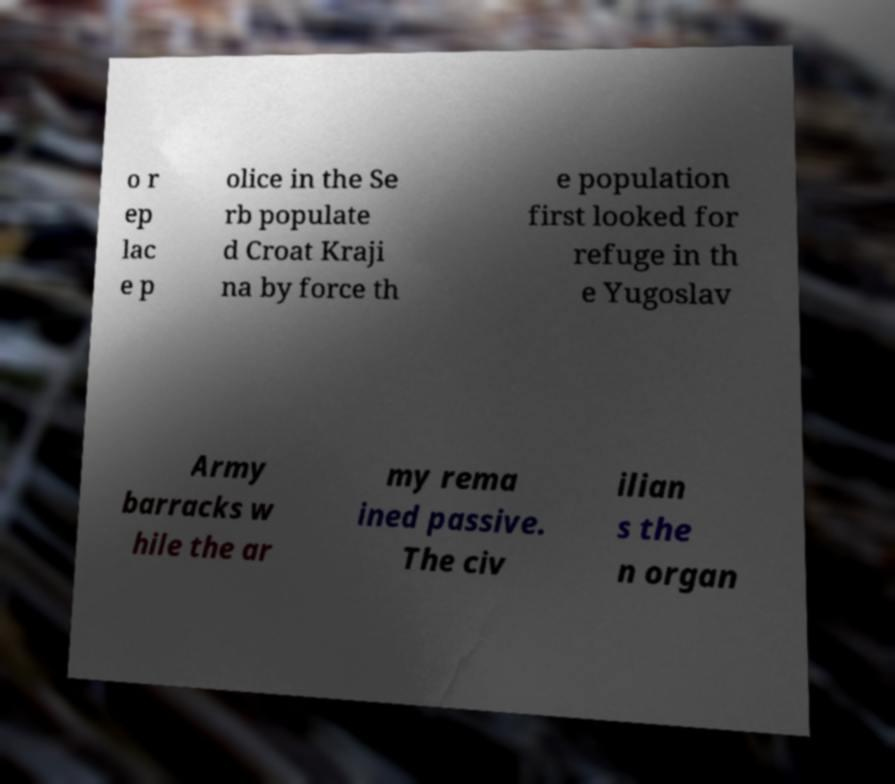What messages or text are displayed in this image? I need them in a readable, typed format. o r ep lac e p olice in the Se rb populate d Croat Kraji na by force th e population first looked for refuge in th e Yugoslav Army barracks w hile the ar my rema ined passive. The civ ilian s the n organ 